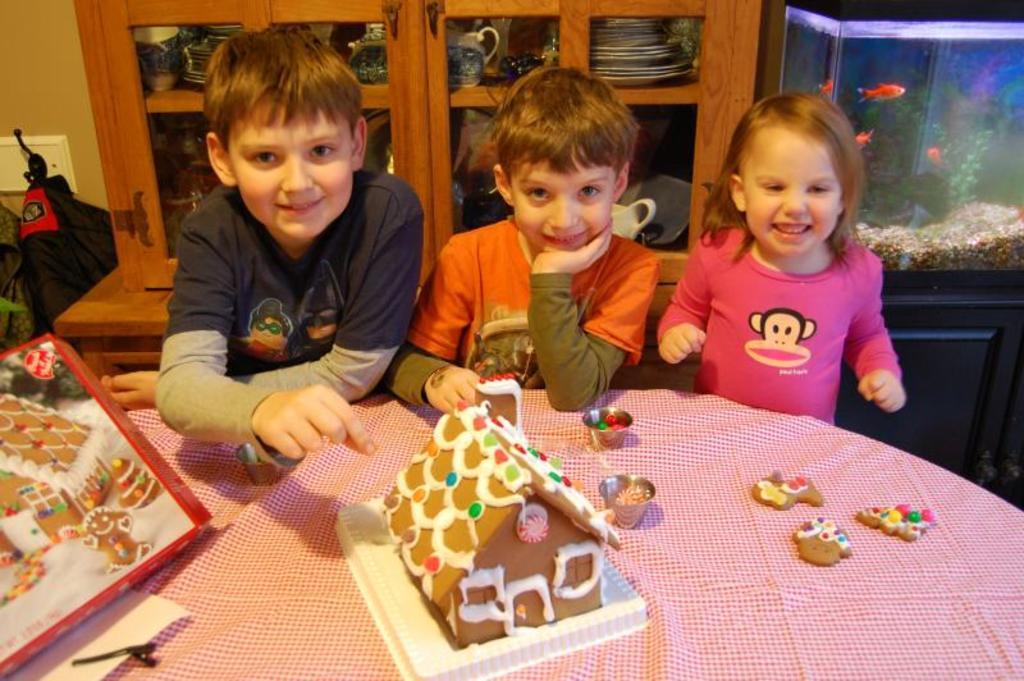How would you summarize this image in a sentence or two? This image is clicked inside a room. There are three children in the middle. There is a table in front of them, on that there is a toy. There are cupboards behind them. There is an aquarium in the top right corner. 